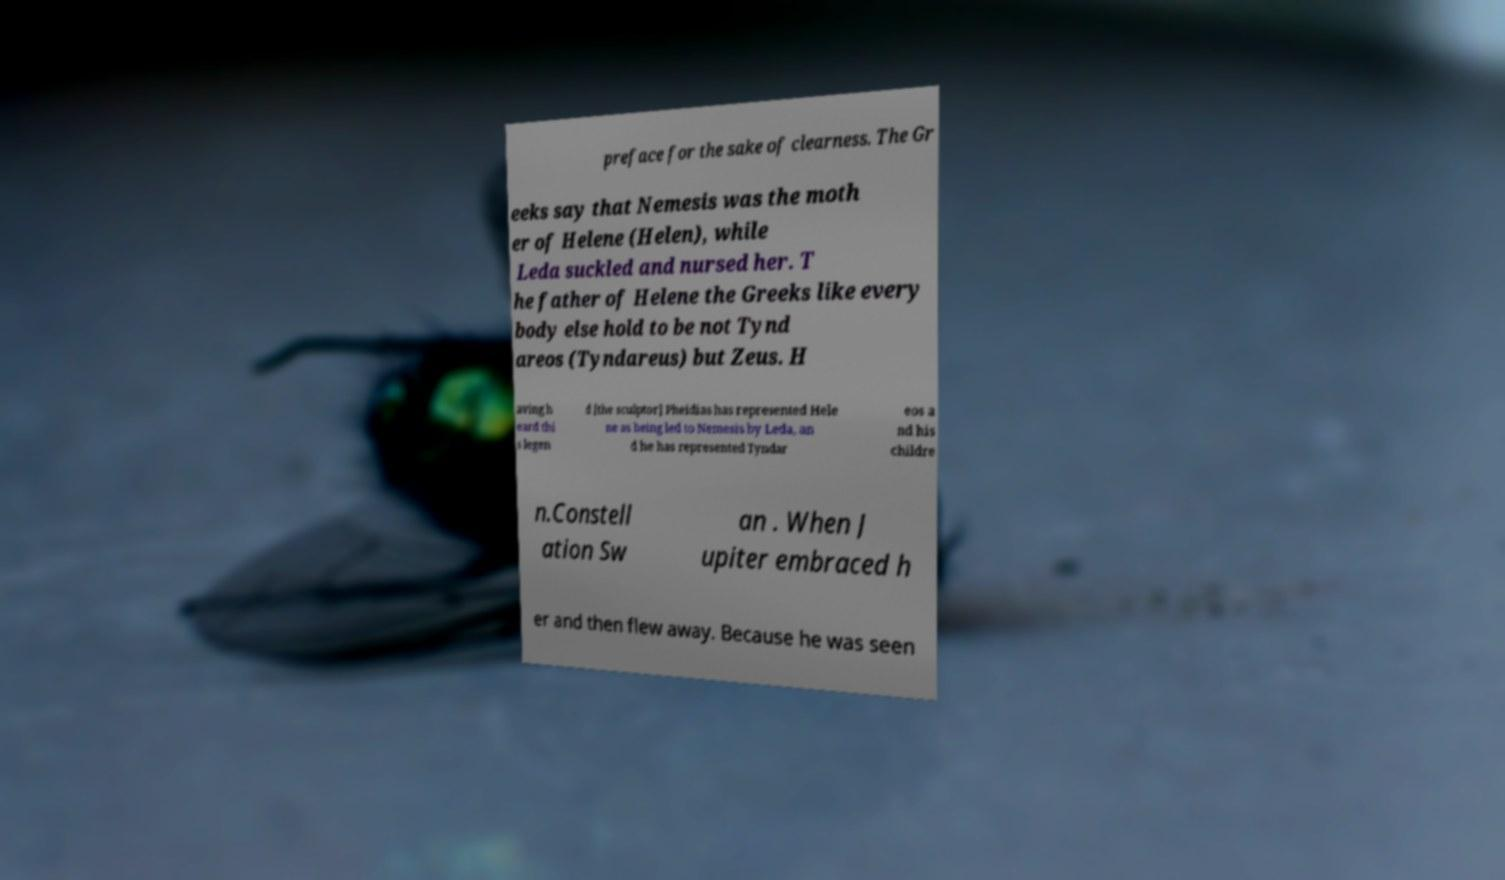Please read and relay the text visible in this image. What does it say? preface for the sake of clearness. The Gr eeks say that Nemesis was the moth er of Helene (Helen), while Leda suckled and nursed her. T he father of Helene the Greeks like every body else hold to be not Tynd areos (Tyndareus) but Zeus. H aving h eard thi s legen d [the sculptor] Pheidias has represented Hele ne as being led to Nemesis by Leda, an d he has represented Tyndar eos a nd his childre n.Constell ation Sw an . When J upiter embraced h er and then flew away. Because he was seen 